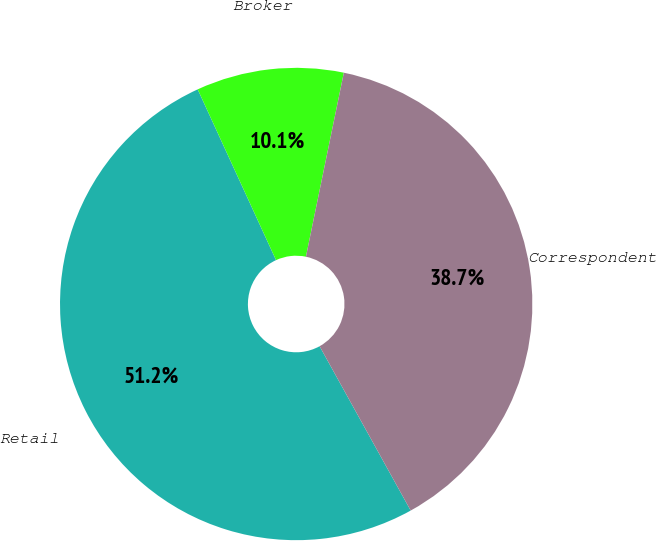Convert chart to OTSL. <chart><loc_0><loc_0><loc_500><loc_500><pie_chart><fcel>Retail<fcel>Broker<fcel>Correspondent<nl><fcel>51.21%<fcel>10.08%<fcel>38.71%<nl></chart> 